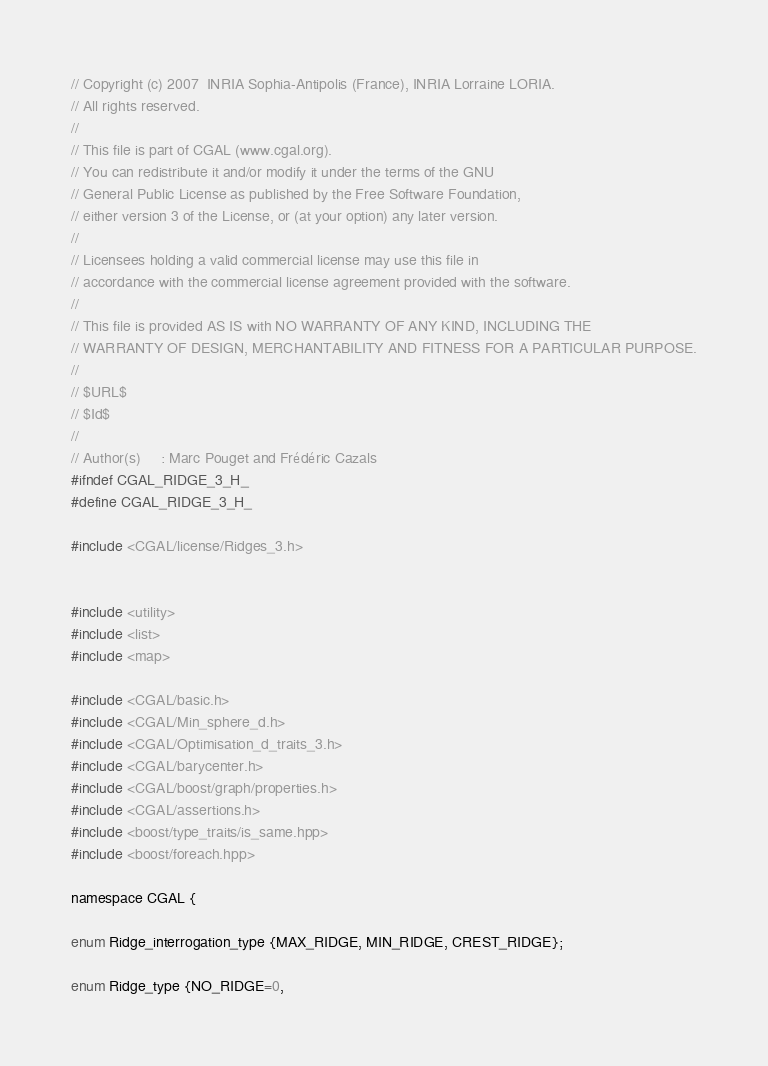Convert code to text. <code><loc_0><loc_0><loc_500><loc_500><_C_>// Copyright (c) 2007  INRIA Sophia-Antipolis (France), INRIA Lorraine LORIA.
// All rights reserved.
//
// This file is part of CGAL (www.cgal.org).
// You can redistribute it and/or modify it under the terms of the GNU
// General Public License as published by the Free Software Foundation,
// either version 3 of the License, or (at your option) any later version.
//
// Licensees holding a valid commercial license may use this file in
// accordance with the commercial license agreement provided with the software.
//
// This file is provided AS IS with NO WARRANTY OF ANY KIND, INCLUDING THE
// WARRANTY OF DESIGN, MERCHANTABILITY AND FITNESS FOR A PARTICULAR PURPOSE.
//
// $URL$
// $Id$
//
// Author(s)     : Marc Pouget and Frédéric Cazals
#ifndef CGAL_RIDGE_3_H_
#define CGAL_RIDGE_3_H_

#include <CGAL/license/Ridges_3.h>


#include <utility>
#include <list>
#include <map>

#include <CGAL/basic.h>
#include <CGAL/Min_sphere_d.h>
#include <CGAL/Optimisation_d_traits_3.h>
#include <CGAL/barycenter.h>
#include <CGAL/boost/graph/properties.h>
#include <CGAL/assertions.h>
#include <boost/type_traits/is_same.hpp>
#include <boost/foreach.hpp>

namespace CGAL {
 
enum Ridge_interrogation_type {MAX_RIDGE, MIN_RIDGE, CREST_RIDGE};

enum Ridge_type {NO_RIDGE=0, </code> 